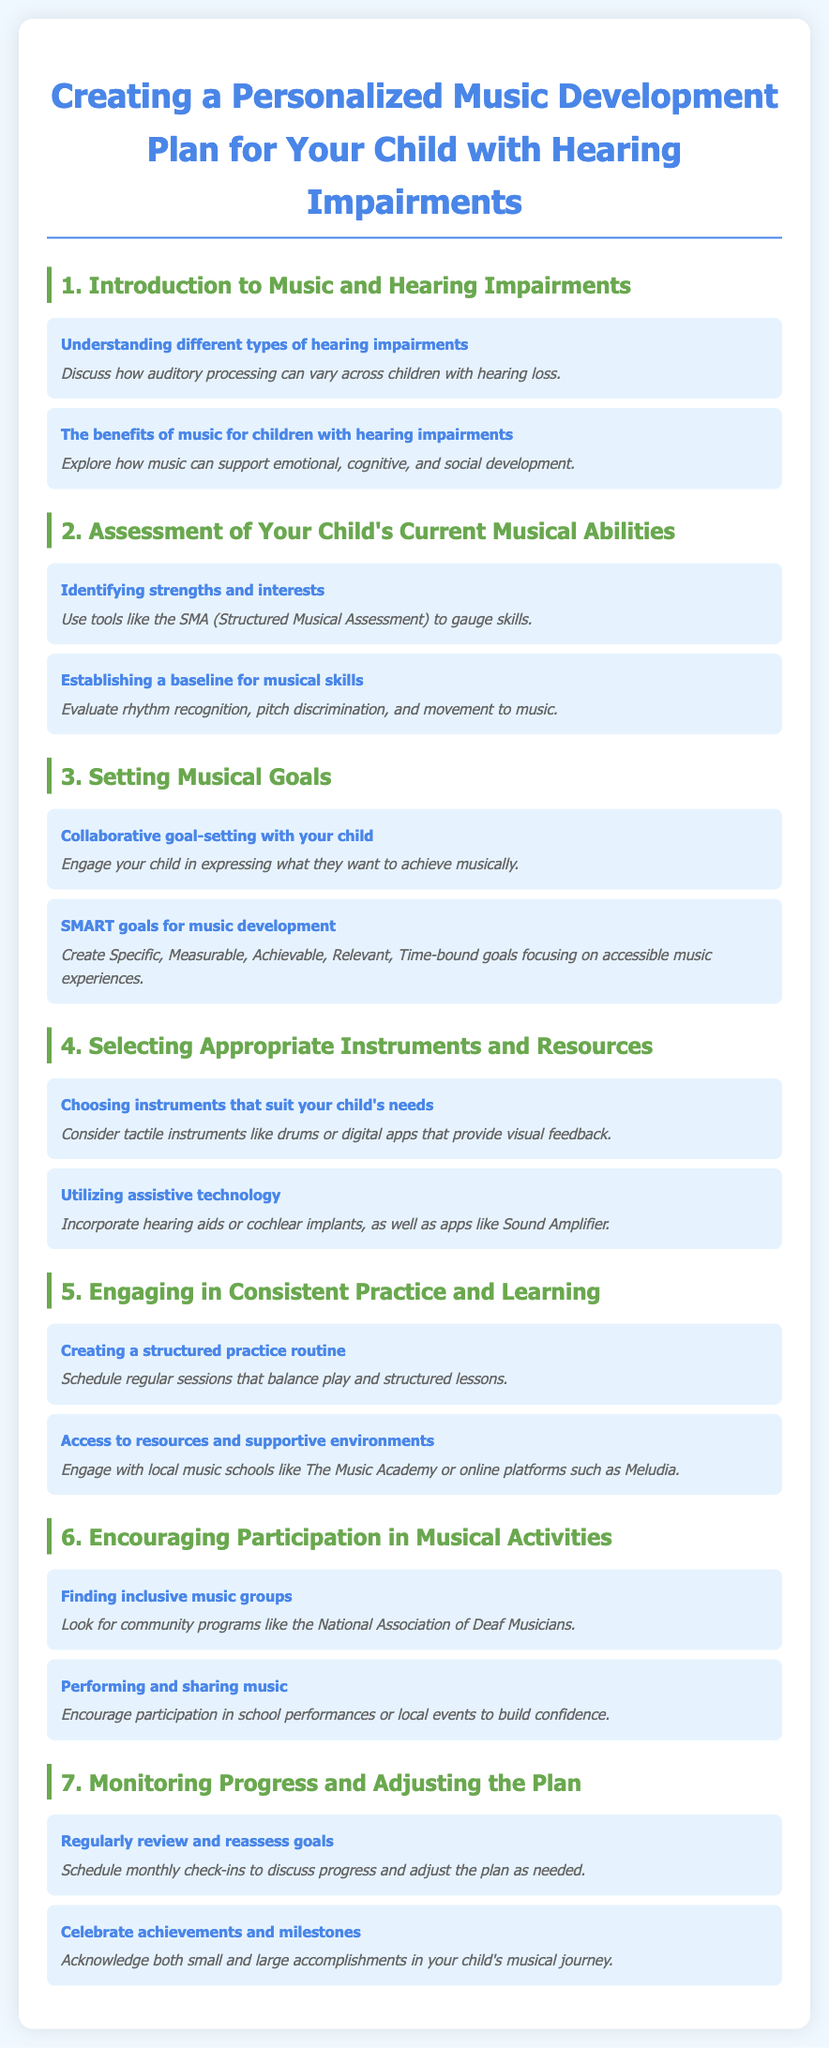what are the benefits of music for children with hearing impairments? The document states that music can support emotional, cognitive, and social development for children with hearing impairments.
Answer: emotional, cognitive, and social development what tool can be used to assess your child's musical abilities? The document mentions using the SMA (Structured Musical Assessment) to gauge skills in children with hearing impairments.
Answer: SMA (Structured Musical Assessment) what does SMART stand for in the context of musical goals? SMART goals in the document are described as Specific, Measurable, Achievable, Relevant, Time-bound, which help in creating effective music development plans.
Answer: Specific, Measurable, Achievable, Relevant, Time-bound which instruments are suggested for children with hearing impairments? The document suggests choosing tactile instruments like drums or digital apps that provide visual feedback as suitable for children with hearing impairments.
Answer: tactile instruments like drums or digital apps how often should you review the musical goals in the plan? The document recommends scheduling monthly check-ins to discuss progress and adjust the plan as needed.
Answer: monthly what type of groups should you look for to encourage participation? The document advises finding inclusive music groups, specifically mentioning community programs like the National Association of Deaf Musicians.
Answer: inclusive music groups what is one example of assistive technology mentioned in the document? The document includes hearing aids and cochlear implants among the suggested assistive technologies to support children with hearing impairments.
Answer: hearing aids or cochlear implants what should you do to celebrate your child's musical progress? The document suggests acknowledging both small and large accomplishments in your child's musical journey to celebrate achievements.
Answer: acknowledge accomplishments 